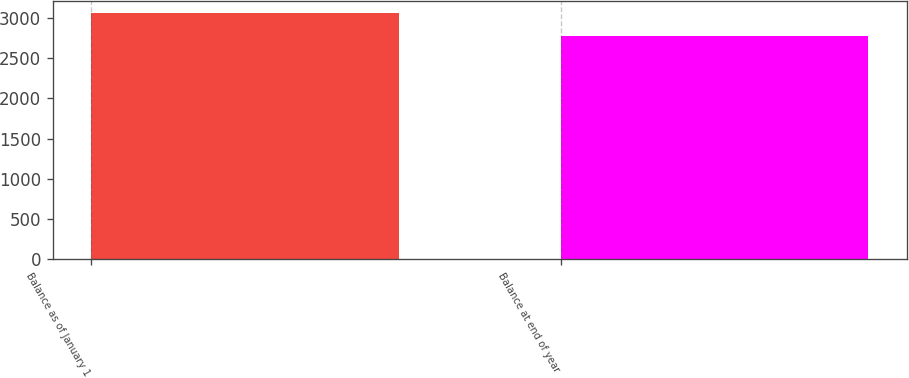Convert chart to OTSL. <chart><loc_0><loc_0><loc_500><loc_500><bar_chart><fcel>Balance as of January 1<fcel>Balance at end of year<nl><fcel>3064.4<fcel>2779.6<nl></chart> 